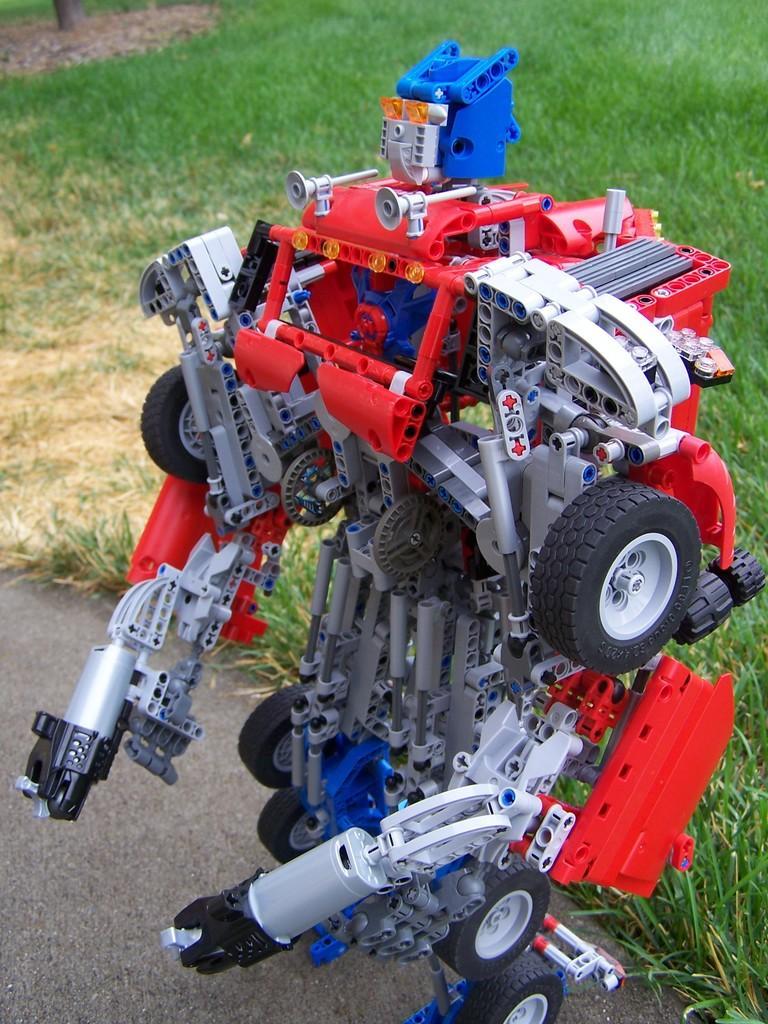How would you summarize this image in a sentence or two? In this image I can see a robot which is red, blue, ash and black in color made up of plastic is on the ground. In the background I can see some grass. 